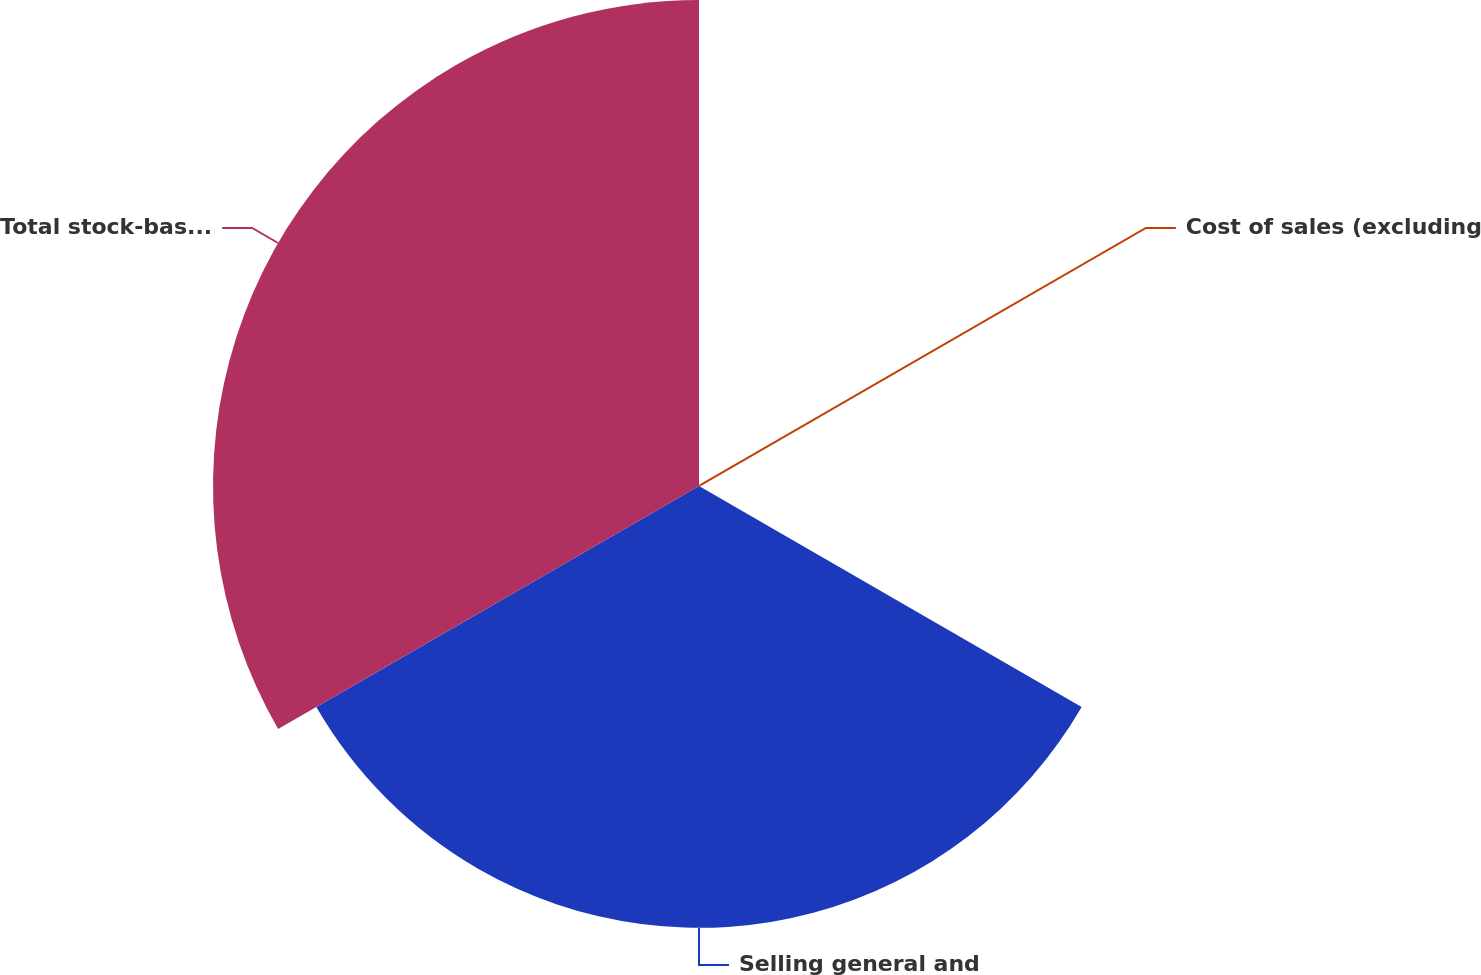Convert chart to OTSL. <chart><loc_0><loc_0><loc_500><loc_500><pie_chart><fcel>Cost of sales (excluding<fcel>Selling general and<fcel>Total stock-based compensation<nl><fcel>0.17%<fcel>47.54%<fcel>52.29%<nl></chart> 